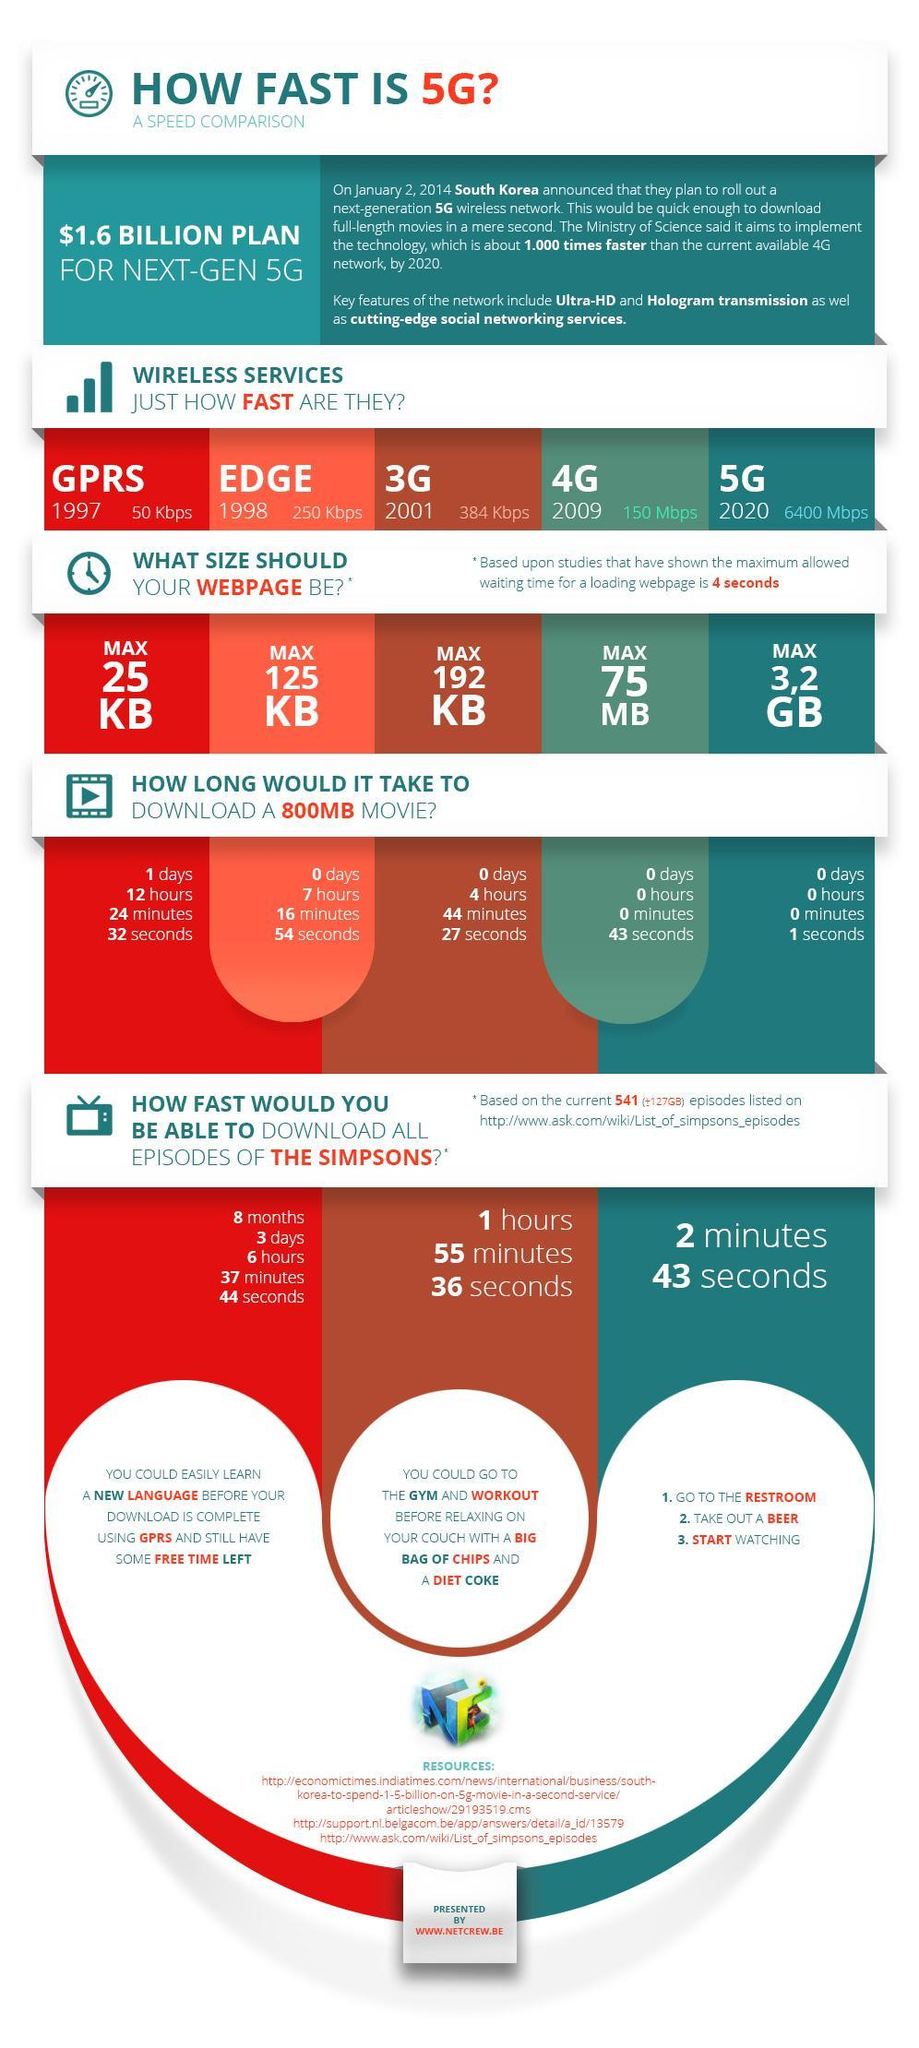How many resources are listed?
Answer the question with a short phrase. 3 